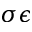Convert formula to latex. <formula><loc_0><loc_0><loc_500><loc_500>\sigma \epsilon</formula> 